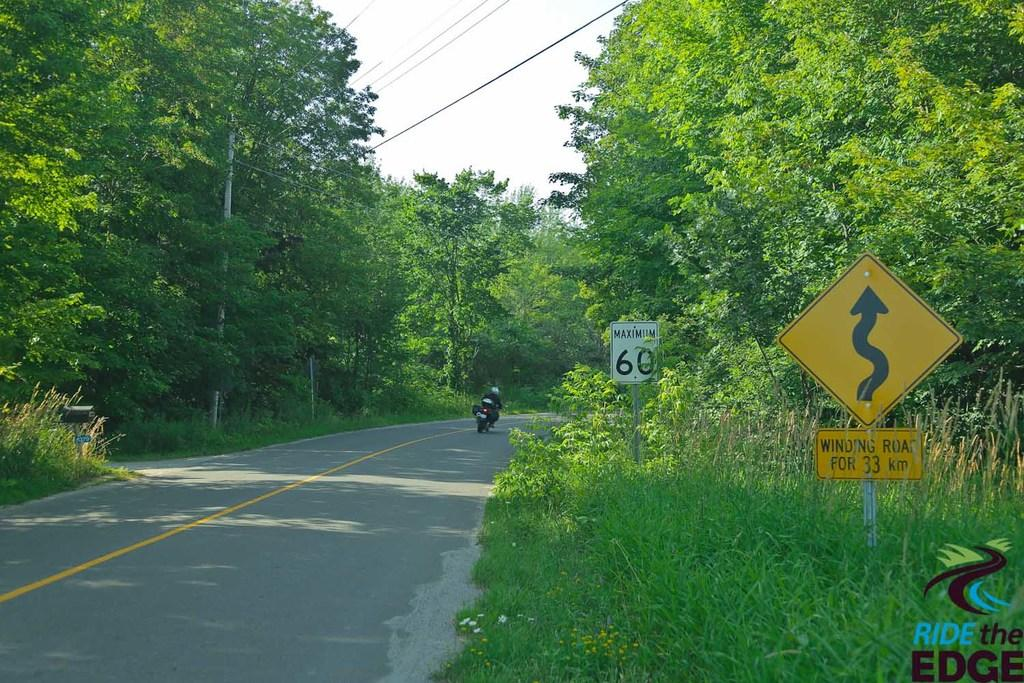<image>
Share a concise interpretation of the image provided. A motorbike flies along a country road passing warning signs and a 60 speed limit sign. 